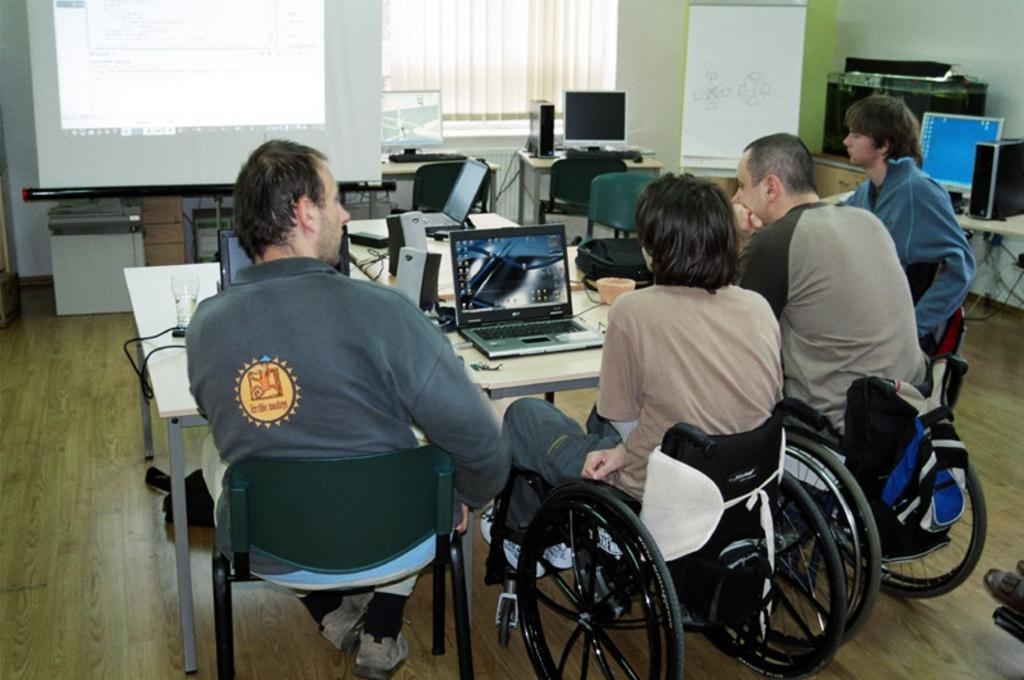How would you summarize this image in a sentence or two? In this image I can see four men in the front. I can see the middle two are sitting on wheelchairs and the rest two are sitting on chairs. In the background I can see few tables, a white colour board, a projector's screen and on these tables I can see few monitors, CPUs, laptops and few other electronic devices. 